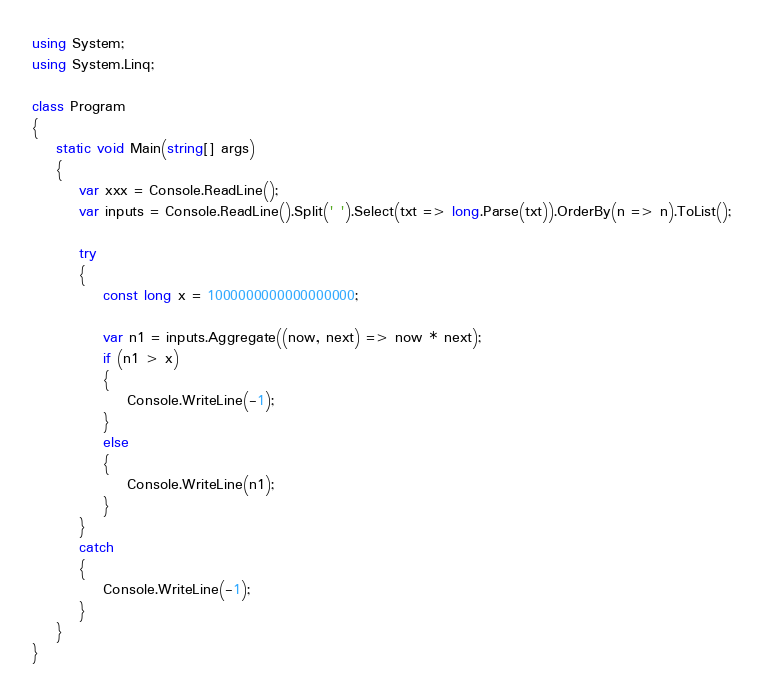Convert code to text. <code><loc_0><loc_0><loc_500><loc_500><_C#_>using System;
using System.Linq;

class Program
{
    static void Main(string[] args)
    {
        var xxx = Console.ReadLine();
        var inputs = Console.ReadLine().Split(' ').Select(txt => long.Parse(txt)).OrderBy(n => n).ToList();

        try
        {
            const long x = 1000000000000000000;

            var n1 = inputs.Aggregate((now, next) => now * next);
            if (n1 > x)
            {
                Console.WriteLine(-1);
            }
            else
            {
                Console.WriteLine(n1);
            }
        }
        catch
        {
            Console.WriteLine(-1);
        }
    }
}</code> 